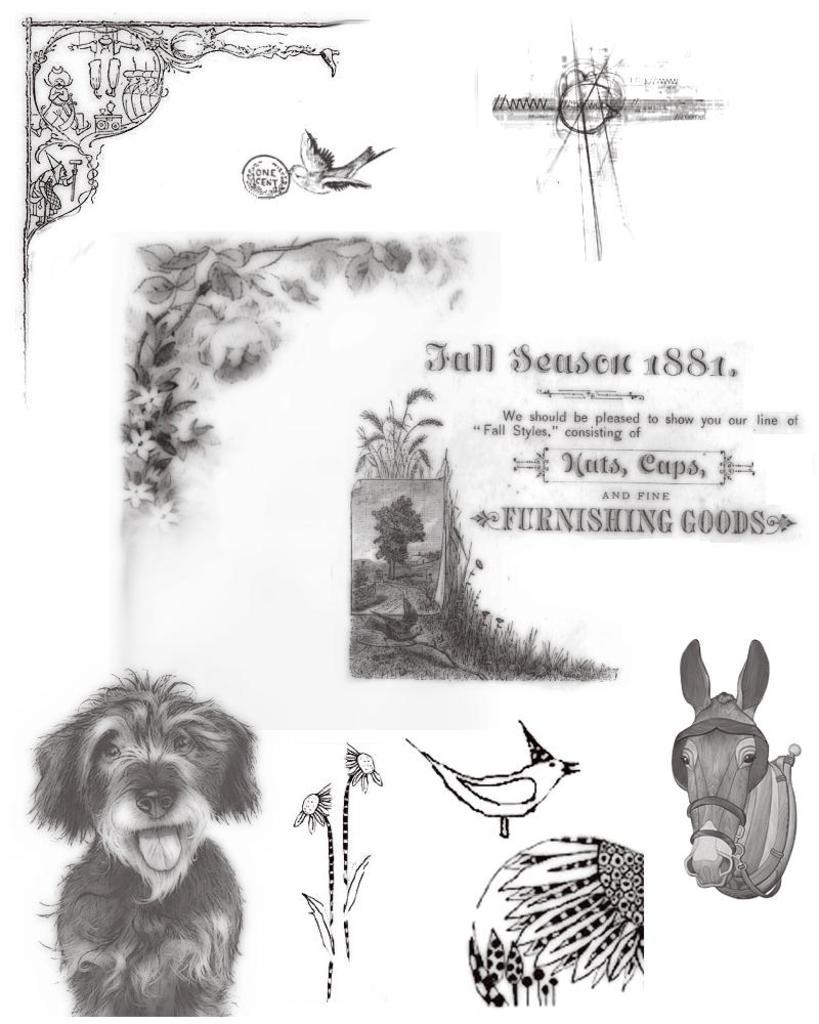What is present in the image that contains visual information? There is a paper in the image that contains drawings. What else can be found on the paper in the image? The paper contains text as well. What type of account is being discussed in the image? There is no account being discussed in the image; it only contains drawings and text on a paper. 